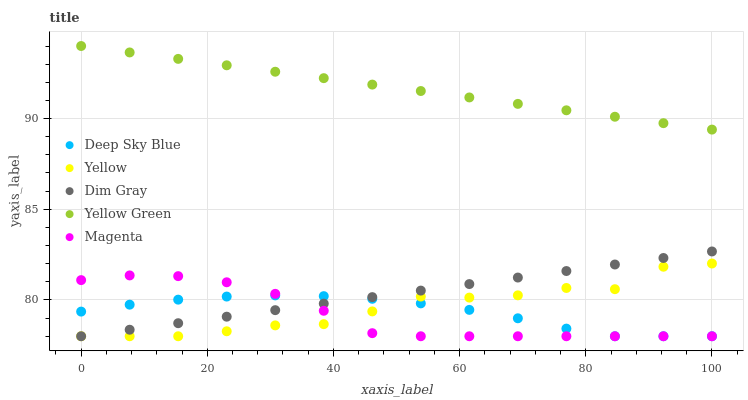Does Magenta have the minimum area under the curve?
Answer yes or no. Yes. Does Yellow Green have the maximum area under the curve?
Answer yes or no. Yes. Does Dim Gray have the minimum area under the curve?
Answer yes or no. No. Does Dim Gray have the maximum area under the curve?
Answer yes or no. No. Is Yellow Green the smoothest?
Answer yes or no. Yes. Is Yellow the roughest?
Answer yes or no. Yes. Is Dim Gray the smoothest?
Answer yes or no. No. Is Dim Gray the roughest?
Answer yes or no. No. Does Magenta have the lowest value?
Answer yes or no. Yes. Does Yellow Green have the lowest value?
Answer yes or no. No. Does Yellow Green have the highest value?
Answer yes or no. Yes. Does Dim Gray have the highest value?
Answer yes or no. No. Is Magenta less than Yellow Green?
Answer yes or no. Yes. Is Yellow Green greater than Dim Gray?
Answer yes or no. Yes. Does Deep Sky Blue intersect Yellow?
Answer yes or no. Yes. Is Deep Sky Blue less than Yellow?
Answer yes or no. No. Is Deep Sky Blue greater than Yellow?
Answer yes or no. No. Does Magenta intersect Yellow Green?
Answer yes or no. No. 